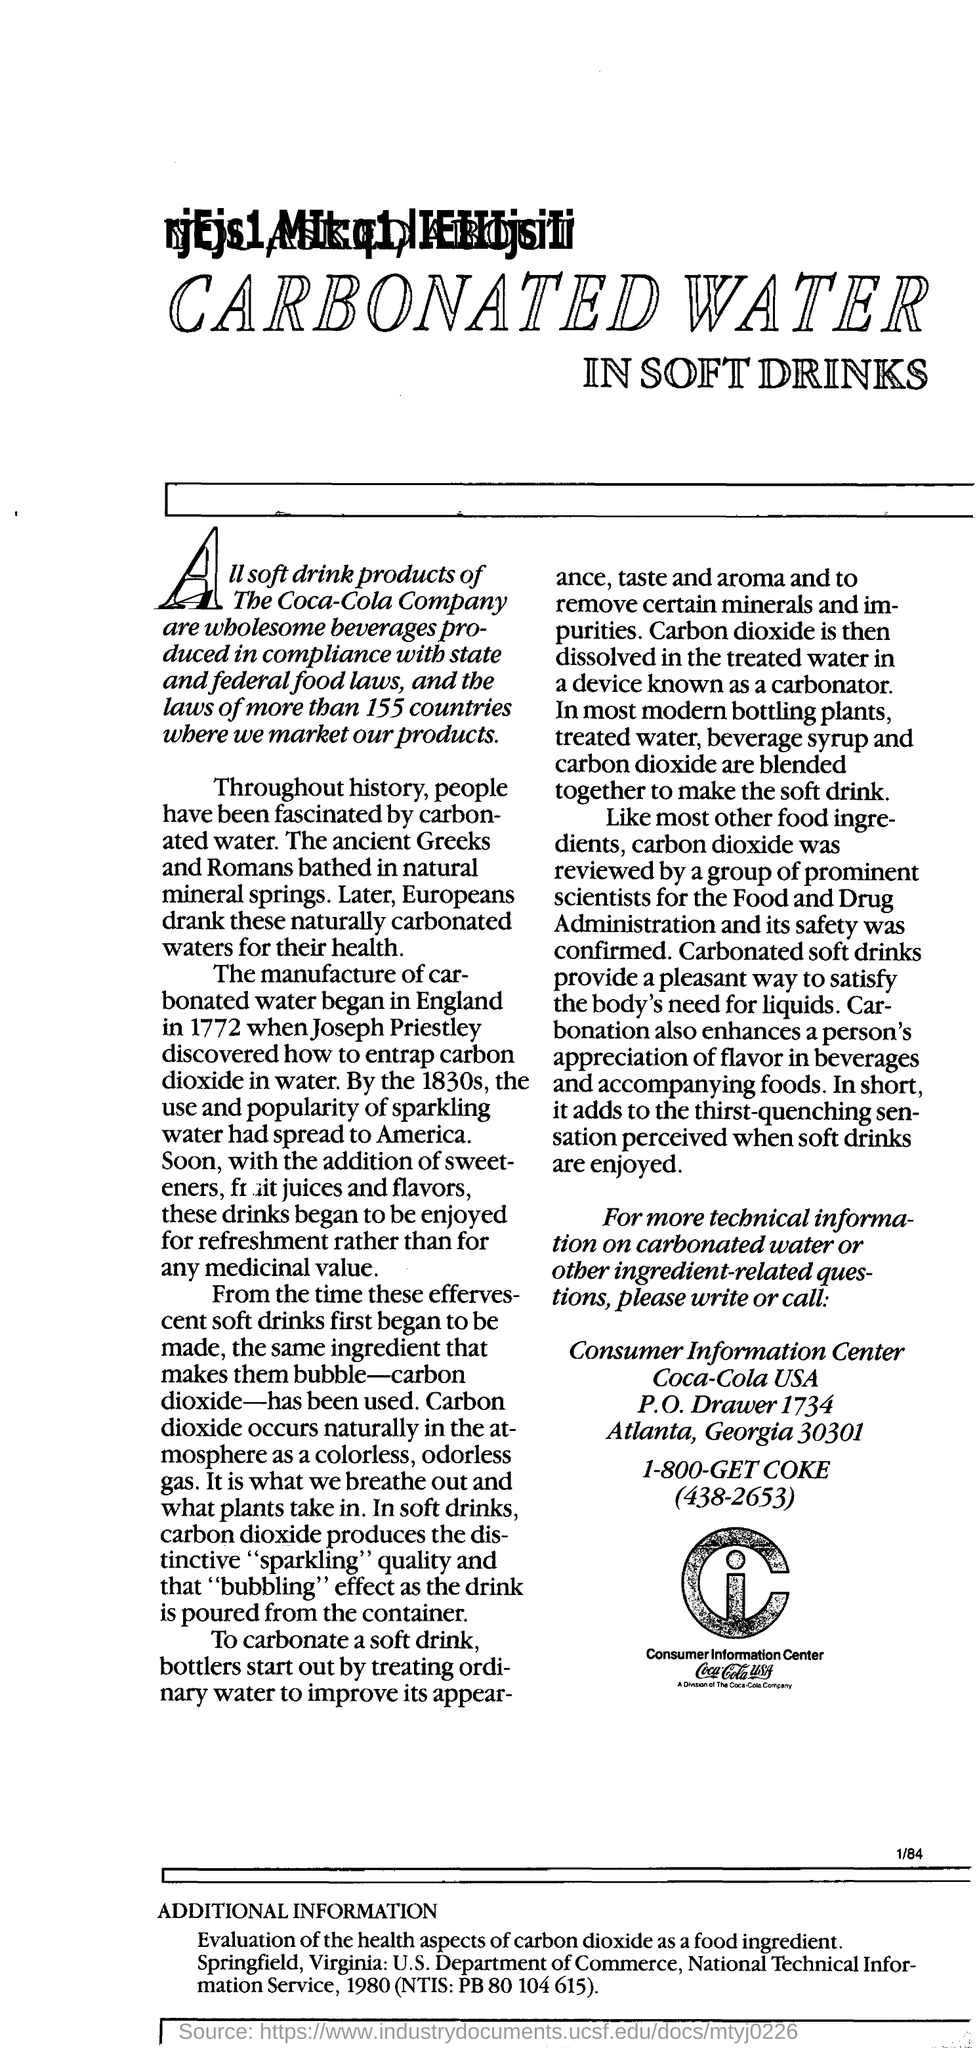In which year manufacture of carbonated water began ?
Your answer should be compact. 1772. In how many countries coca-cola markets its products?
Keep it short and to the point. More than 155 countries. What does the carbon dioxide  produce in soft drinks ?
Ensure brevity in your answer.  Produces the distinctive "sparkling" quality and that "bubbling" effect as the drink is poured from the container. Who reviewed about the safety of carbon dioxide in food?
Provide a succinct answer. By a group of prominent scientists for the food and drug administration. Which company's consumer information center is given here?
Offer a very short reply. Coca-Cola USA. 